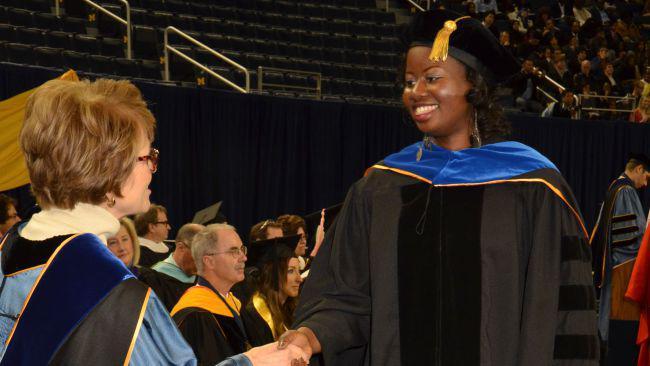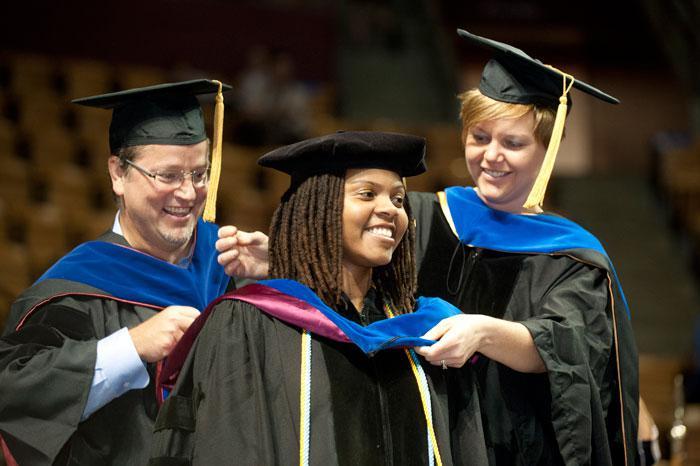The first image is the image on the left, the second image is the image on the right. Evaluate the accuracy of this statement regarding the images: "There are 12 or more students wearing all-blue graduation gowns with white lapels.". Is it true? Answer yes or no. No. The first image is the image on the left, the second image is the image on the right. Given the left and right images, does the statement "There is a group of students walking in a line in the left image." hold true? Answer yes or no. No. 